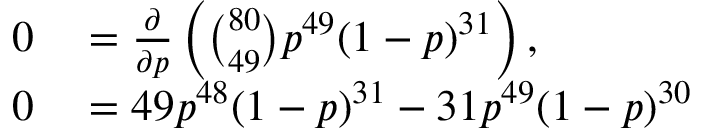Convert formula to latex. <formula><loc_0><loc_0><loc_500><loc_500>\begin{array} { r l } { 0 } & = { \frac { \partial } { \partial p } } \left ( { \binom { 8 0 } { 4 9 } } p ^ { 4 9 } ( 1 - p ) ^ { 3 1 } \right ) , } \\ { 0 } & = 4 9 p ^ { 4 8 } ( 1 - p ) ^ { 3 1 } - 3 1 p ^ { 4 9 } ( 1 - p ) ^ { 3 0 } } \end{array}</formula> 